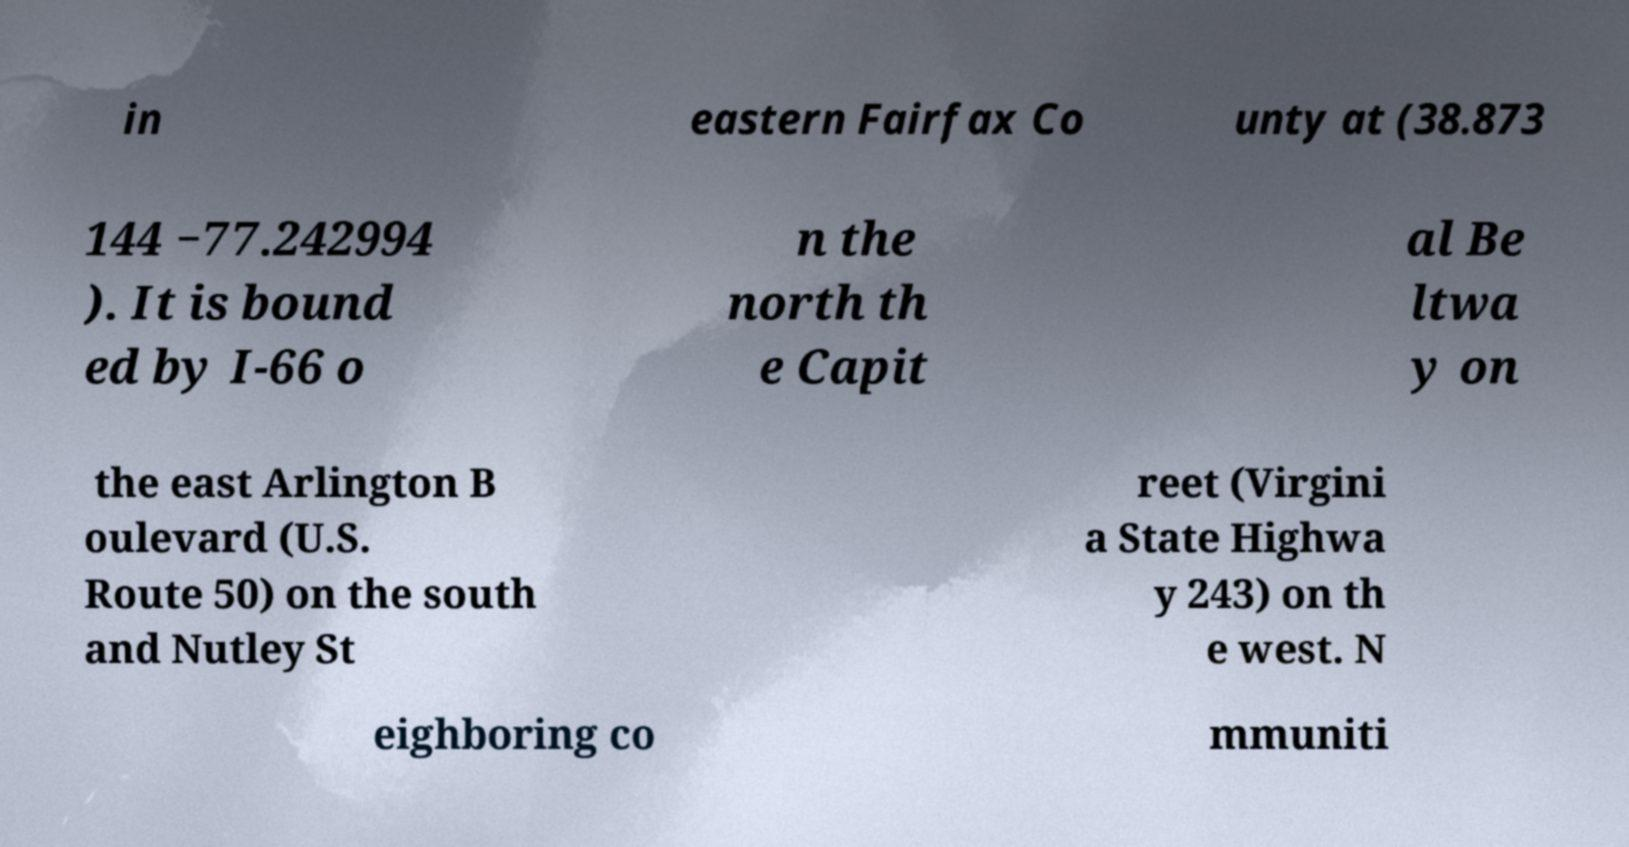For documentation purposes, I need the text within this image transcribed. Could you provide that? in eastern Fairfax Co unty at (38.873 144 −77.242994 ). It is bound ed by I-66 o n the north th e Capit al Be ltwa y on the east Arlington B oulevard (U.S. Route 50) on the south and Nutley St reet (Virgini a State Highwa y 243) on th e west. N eighboring co mmuniti 